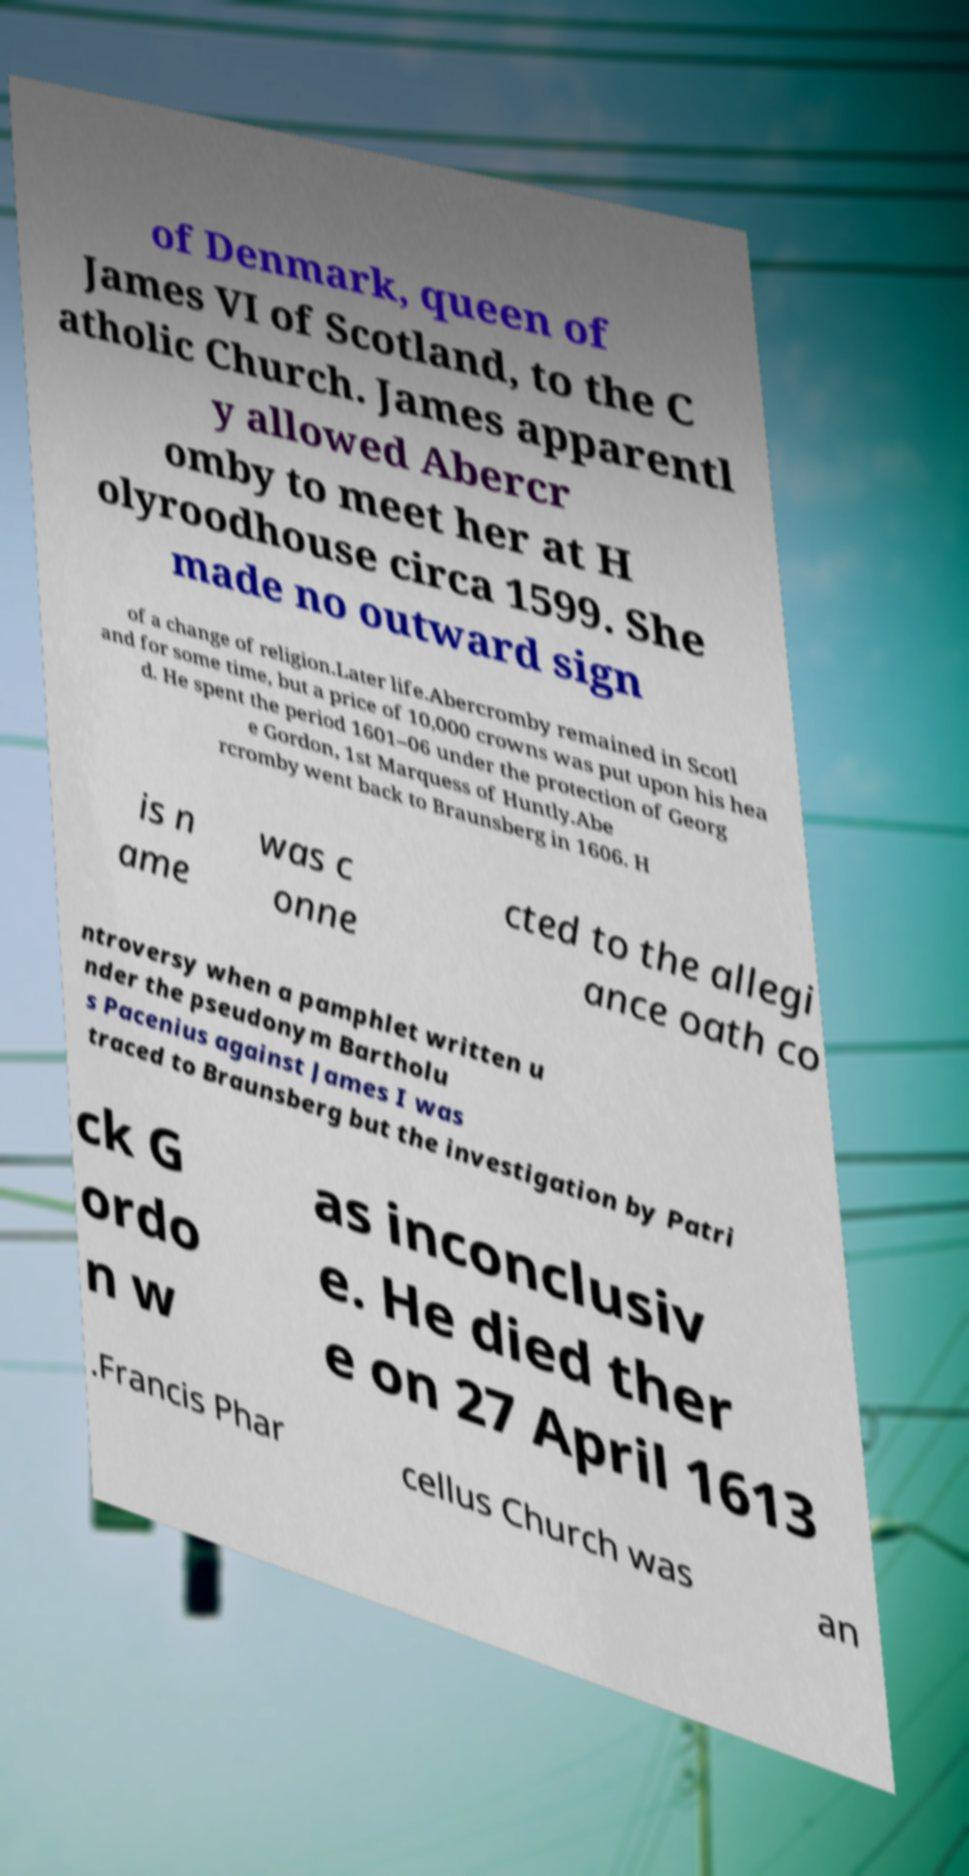I need the written content from this picture converted into text. Can you do that? of Denmark, queen of James VI of Scotland, to the C atholic Church. James apparentl y allowed Abercr omby to meet her at H olyroodhouse circa 1599. She made no outward sign of a change of religion.Later life.Abercromby remained in Scotl and for some time, but a price of 10,000 crowns was put upon his hea d. He spent the period 1601–06 under the protection of Georg e Gordon, 1st Marquess of Huntly.Abe rcromby went back to Braunsberg in 1606. H is n ame was c onne cted to the allegi ance oath co ntroversy when a pamphlet written u nder the pseudonym Bartholu s Pacenius against James I was traced to Braunsberg but the investigation by Patri ck G ordo n w as inconclusiv e. He died ther e on 27 April 1613 .Francis Phar cellus Church was an 